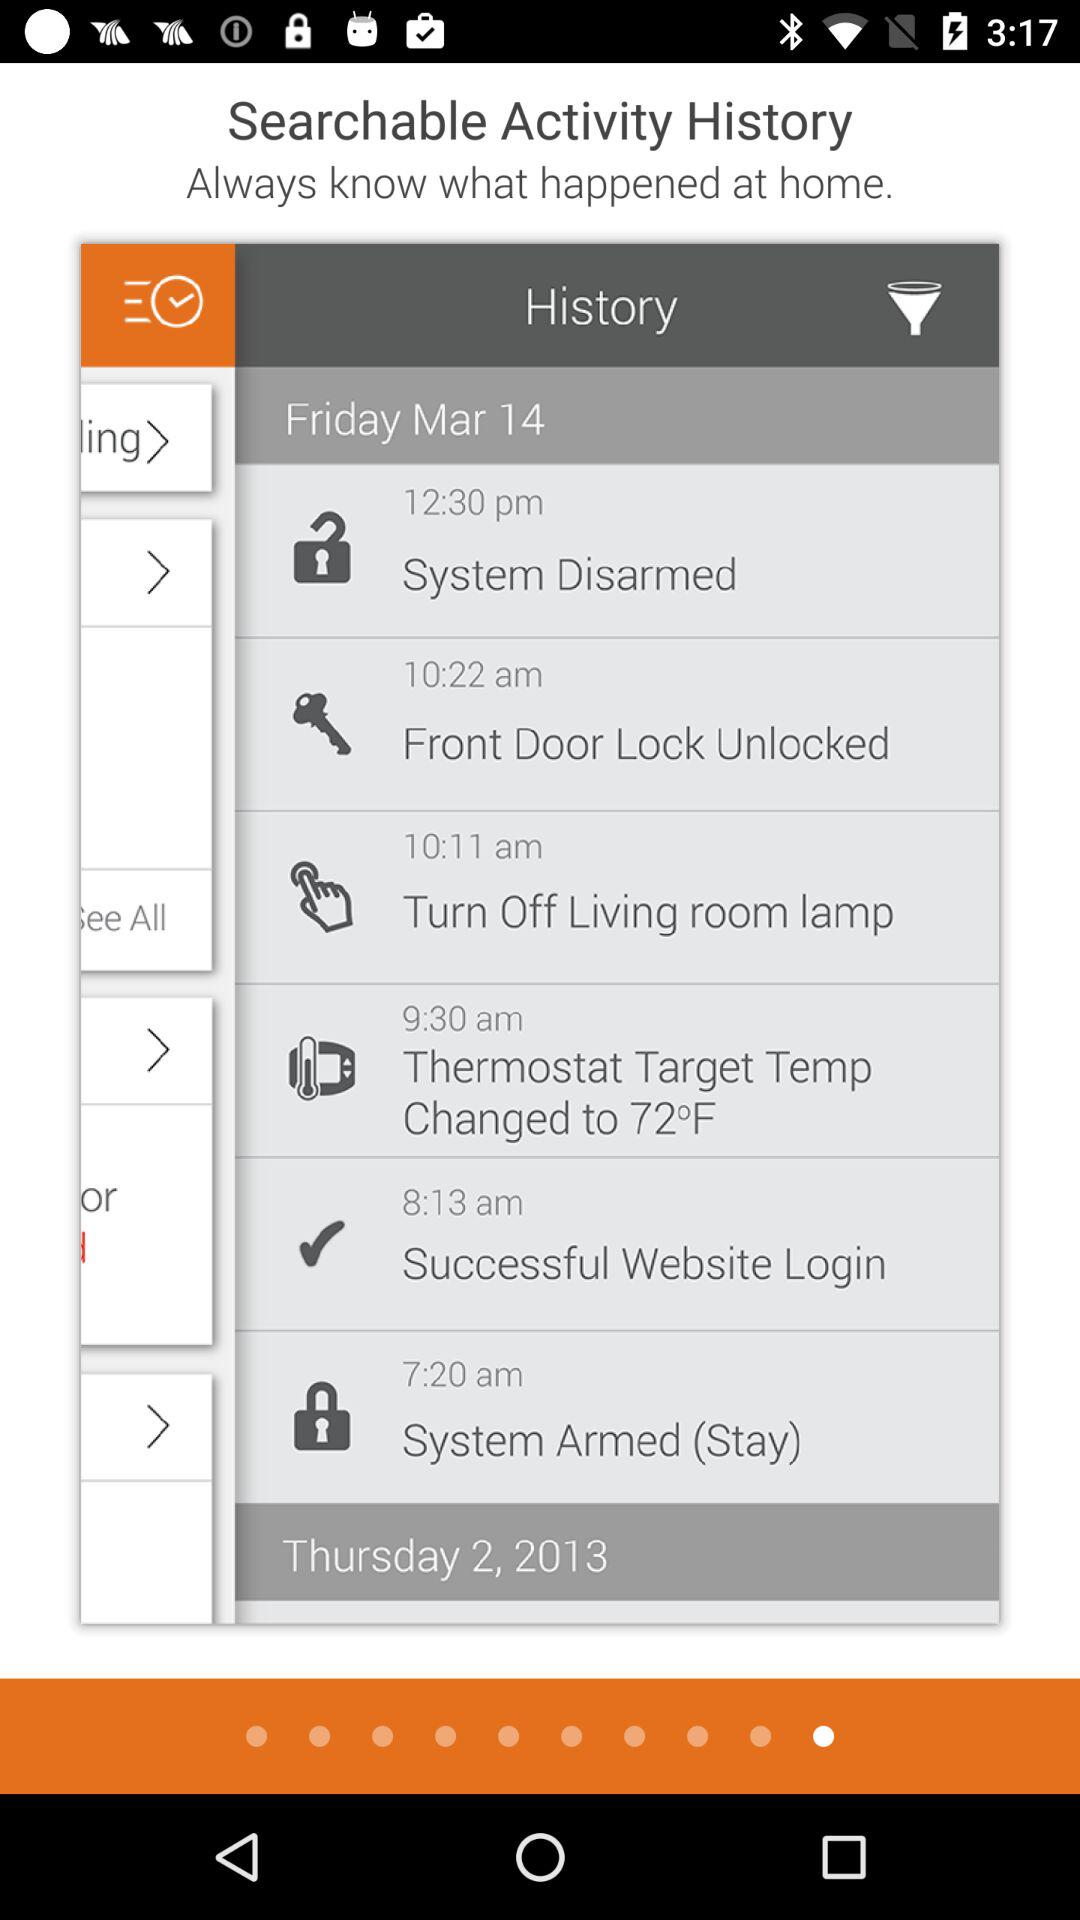Which day falls on March 14? The day is Friday. 